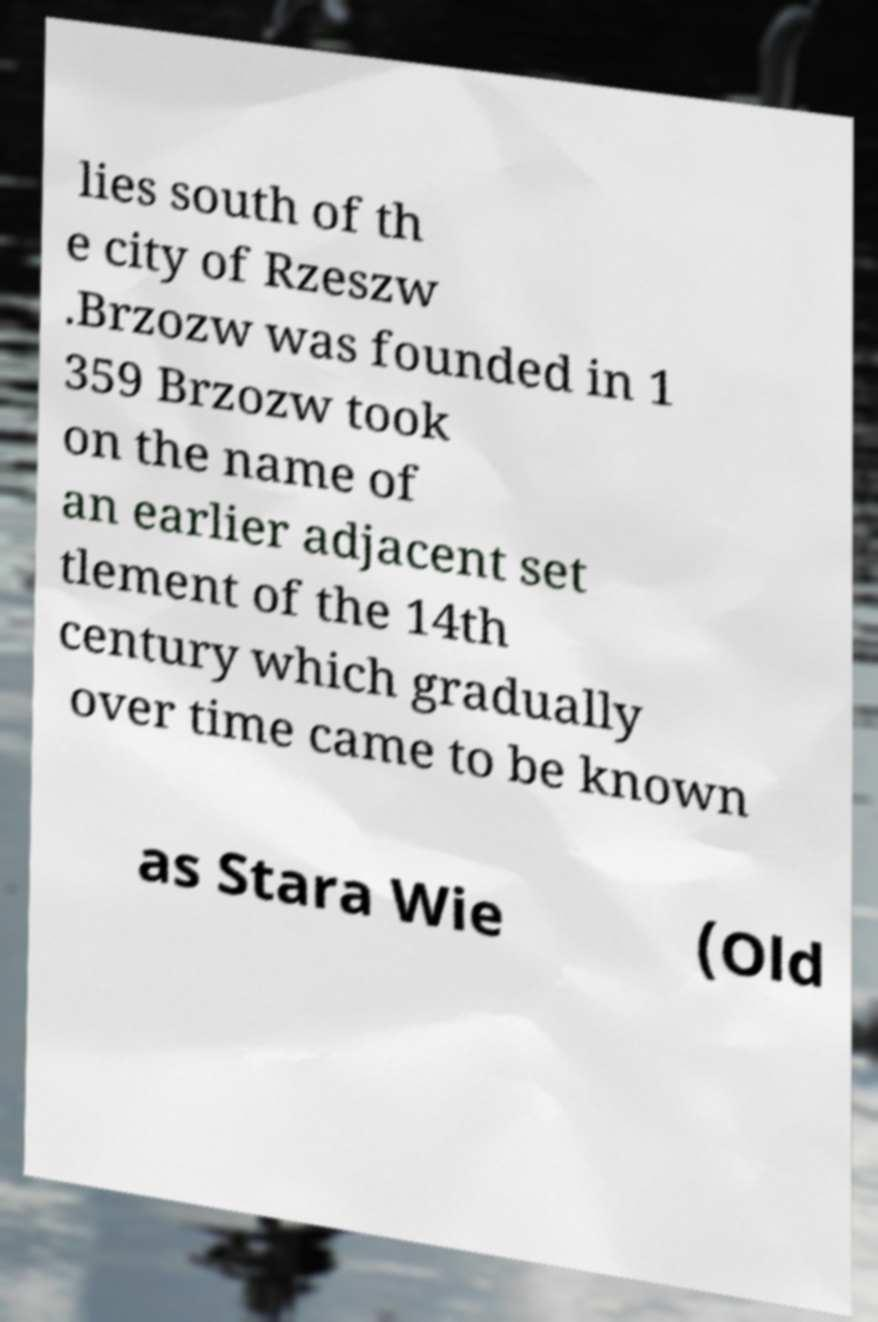I need the written content from this picture converted into text. Can you do that? lies south of th e city of Rzeszw .Brzozw was founded in 1 359 Brzozw took on the name of an earlier adjacent set tlement of the 14th century which gradually over time came to be known as Stara Wie (Old 